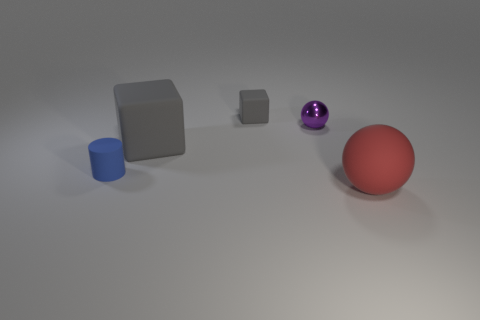Add 3 purple metal things. How many objects exist? 8 Subtract all spheres. How many objects are left? 3 Add 1 big green metal spheres. How many big green metal spheres exist? 1 Subtract 0 red cylinders. How many objects are left? 5 Subtract all blue blocks. Subtract all blue spheres. How many blocks are left? 2 Subtract all purple metallic things. Subtract all big cyan matte cubes. How many objects are left? 4 Add 1 shiny balls. How many shiny balls are left? 2 